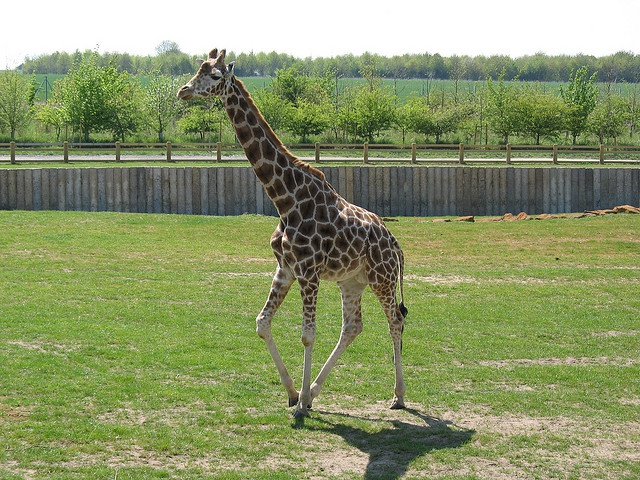Describe the objects in this image and their specific colors. I can see a giraffe in white, black, gray, and olive tones in this image. 